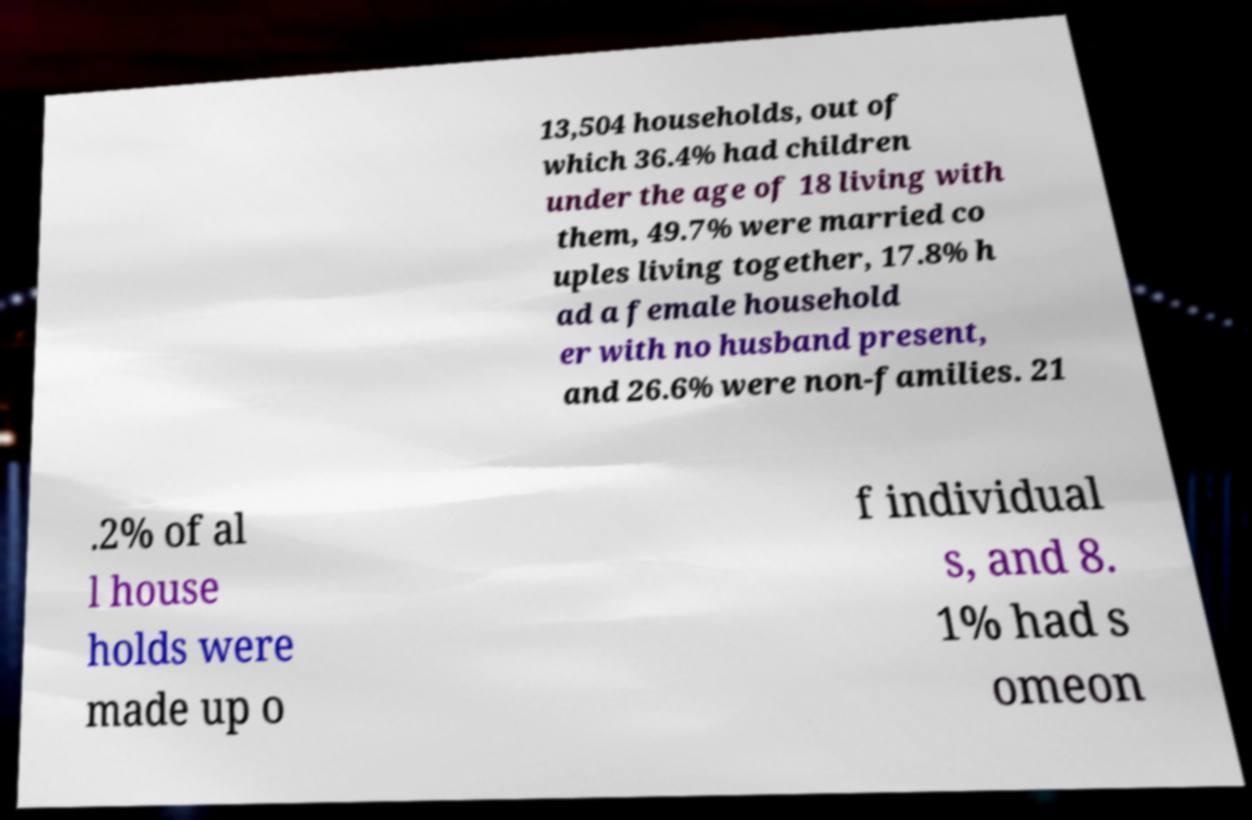Please identify and transcribe the text found in this image. 13,504 households, out of which 36.4% had children under the age of 18 living with them, 49.7% were married co uples living together, 17.8% h ad a female household er with no husband present, and 26.6% were non-families. 21 .2% of al l house holds were made up o f individual s, and 8. 1% had s omeon 